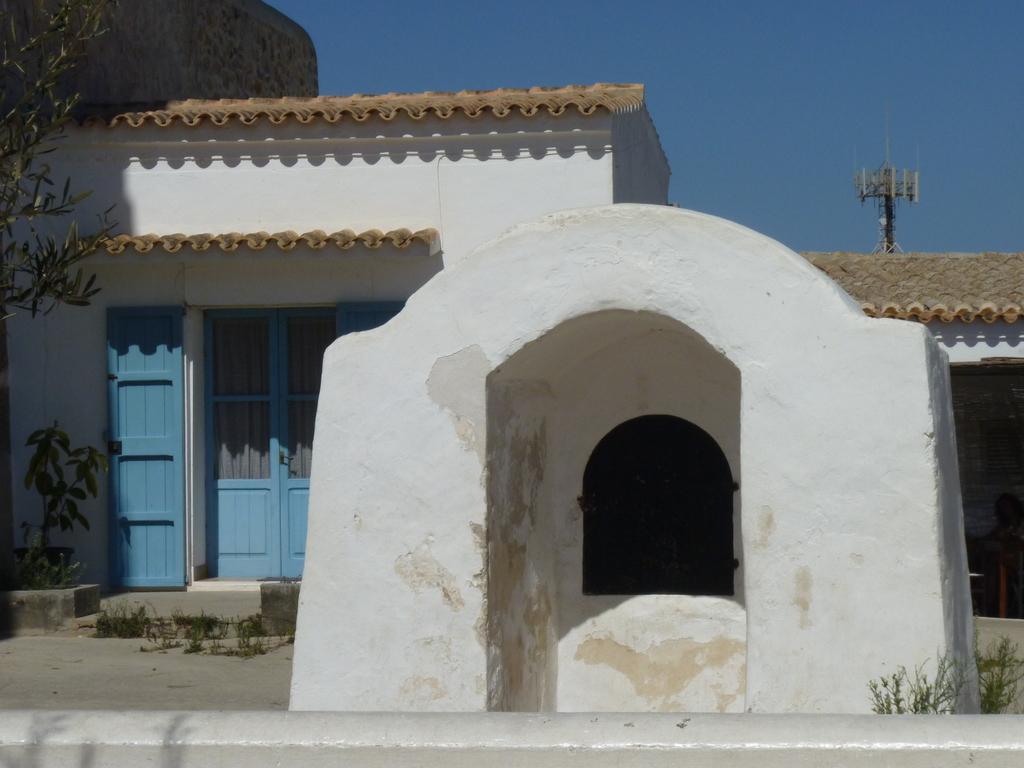In one or two sentences, can you explain what this image depicts? In this picture I can see a building and few plants in front. In the background I can see a pole and the clear sky. 